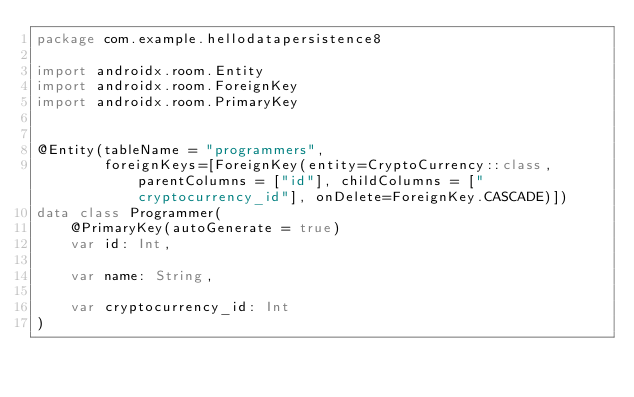<code> <loc_0><loc_0><loc_500><loc_500><_Kotlin_>package com.example.hellodatapersistence8

import androidx.room.Entity
import androidx.room.ForeignKey
import androidx.room.PrimaryKey


@Entity(tableName = "programmers",
        foreignKeys=[ForeignKey(entity=CryptoCurrency::class, parentColumns = ["id"], childColumns = ["cryptocurrency_id"], onDelete=ForeignKey.CASCADE)])
data class Programmer(
    @PrimaryKey(autoGenerate = true)
    var id: Int,

    var name: String,

    var cryptocurrency_id: Int
)</code> 